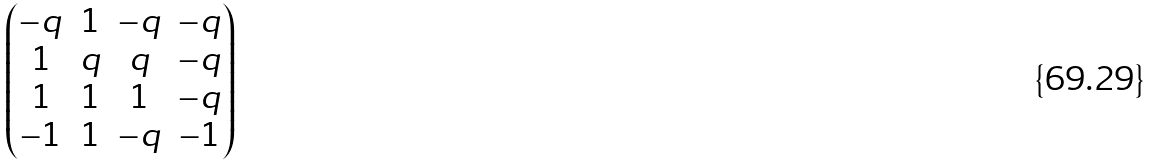Convert formula to latex. <formula><loc_0><loc_0><loc_500><loc_500>\begin{pmatrix} - q & 1 & - q & - q \\ 1 & q & q & - q \\ 1 & 1 & 1 & - q \\ - 1 & 1 & - q & - 1 \end{pmatrix}</formula> 